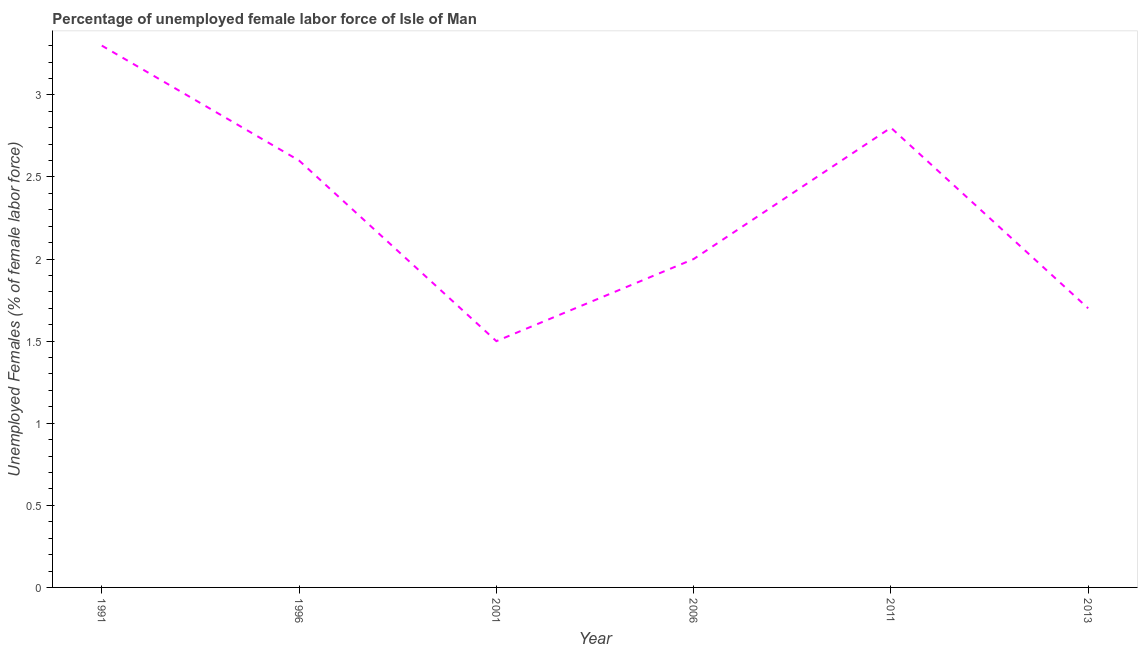What is the total unemployed female labour force in 1991?
Your answer should be compact. 3.3. Across all years, what is the maximum total unemployed female labour force?
Ensure brevity in your answer.  3.3. Across all years, what is the minimum total unemployed female labour force?
Make the answer very short. 1.5. What is the sum of the total unemployed female labour force?
Provide a short and direct response. 13.9. What is the difference between the total unemployed female labour force in 1991 and 2011?
Make the answer very short. 0.5. What is the average total unemployed female labour force per year?
Offer a terse response. 2.32. What is the median total unemployed female labour force?
Ensure brevity in your answer.  2.3. In how many years, is the total unemployed female labour force greater than 1 %?
Provide a succinct answer. 6. What is the ratio of the total unemployed female labour force in 1991 to that in 2011?
Offer a terse response. 1.18. Is the total unemployed female labour force in 1996 less than that in 2013?
Offer a terse response. No. Is the difference between the total unemployed female labour force in 1996 and 2013 greater than the difference between any two years?
Give a very brief answer. No. What is the difference between the highest and the second highest total unemployed female labour force?
Your answer should be very brief. 0.5. What is the difference between the highest and the lowest total unemployed female labour force?
Ensure brevity in your answer.  1.8. In how many years, is the total unemployed female labour force greater than the average total unemployed female labour force taken over all years?
Offer a terse response. 3. How many years are there in the graph?
Ensure brevity in your answer.  6. What is the difference between two consecutive major ticks on the Y-axis?
Your answer should be very brief. 0.5. Are the values on the major ticks of Y-axis written in scientific E-notation?
Keep it short and to the point. No. Does the graph contain any zero values?
Keep it short and to the point. No. Does the graph contain grids?
Provide a short and direct response. No. What is the title of the graph?
Offer a terse response. Percentage of unemployed female labor force of Isle of Man. What is the label or title of the X-axis?
Your response must be concise. Year. What is the label or title of the Y-axis?
Provide a succinct answer. Unemployed Females (% of female labor force). What is the Unemployed Females (% of female labor force) in 1991?
Keep it short and to the point. 3.3. What is the Unemployed Females (% of female labor force) in 1996?
Provide a short and direct response. 2.6. What is the Unemployed Females (% of female labor force) of 2001?
Offer a very short reply. 1.5. What is the Unemployed Females (% of female labor force) in 2011?
Make the answer very short. 2.8. What is the Unemployed Females (% of female labor force) of 2013?
Your response must be concise. 1.7. What is the difference between the Unemployed Females (% of female labor force) in 1996 and 2013?
Provide a succinct answer. 0.9. What is the difference between the Unemployed Females (% of female labor force) in 2001 and 2011?
Provide a succinct answer. -1.3. What is the difference between the Unemployed Females (% of female labor force) in 2001 and 2013?
Your answer should be very brief. -0.2. What is the difference between the Unemployed Females (% of female labor force) in 2006 and 2013?
Your answer should be very brief. 0.3. What is the difference between the Unemployed Females (% of female labor force) in 2011 and 2013?
Ensure brevity in your answer.  1.1. What is the ratio of the Unemployed Females (% of female labor force) in 1991 to that in 1996?
Provide a succinct answer. 1.27. What is the ratio of the Unemployed Females (% of female labor force) in 1991 to that in 2006?
Provide a succinct answer. 1.65. What is the ratio of the Unemployed Females (% of female labor force) in 1991 to that in 2011?
Your response must be concise. 1.18. What is the ratio of the Unemployed Females (% of female labor force) in 1991 to that in 2013?
Keep it short and to the point. 1.94. What is the ratio of the Unemployed Females (% of female labor force) in 1996 to that in 2001?
Offer a very short reply. 1.73. What is the ratio of the Unemployed Females (% of female labor force) in 1996 to that in 2006?
Your answer should be compact. 1.3. What is the ratio of the Unemployed Females (% of female labor force) in 1996 to that in 2011?
Your answer should be compact. 0.93. What is the ratio of the Unemployed Females (% of female labor force) in 1996 to that in 2013?
Ensure brevity in your answer.  1.53. What is the ratio of the Unemployed Females (% of female labor force) in 2001 to that in 2006?
Your answer should be very brief. 0.75. What is the ratio of the Unemployed Females (% of female labor force) in 2001 to that in 2011?
Provide a short and direct response. 0.54. What is the ratio of the Unemployed Females (% of female labor force) in 2001 to that in 2013?
Your response must be concise. 0.88. What is the ratio of the Unemployed Females (% of female labor force) in 2006 to that in 2011?
Provide a succinct answer. 0.71. What is the ratio of the Unemployed Females (% of female labor force) in 2006 to that in 2013?
Offer a very short reply. 1.18. What is the ratio of the Unemployed Females (% of female labor force) in 2011 to that in 2013?
Provide a short and direct response. 1.65. 